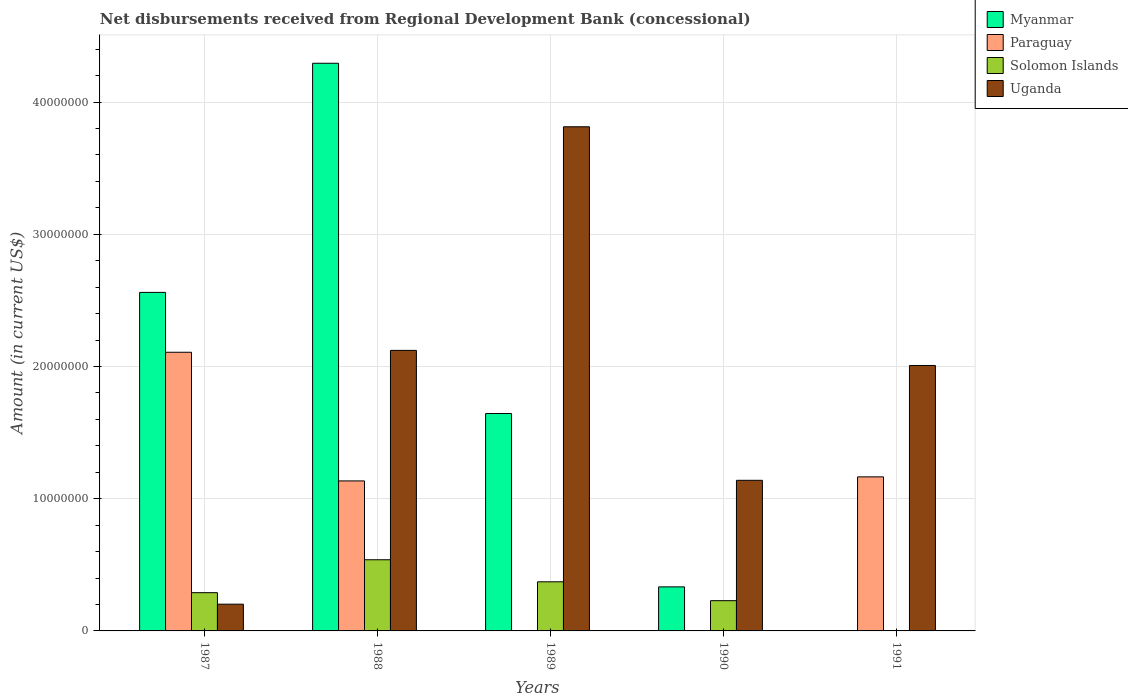How many groups of bars are there?
Give a very brief answer. 5. How many bars are there on the 5th tick from the right?
Your answer should be very brief. 4. What is the label of the 2nd group of bars from the left?
Your response must be concise. 1988. What is the amount of disbursements received from Regional Development Bank in Myanmar in 1987?
Offer a terse response. 2.56e+07. Across all years, what is the maximum amount of disbursements received from Regional Development Bank in Myanmar?
Your response must be concise. 4.29e+07. Across all years, what is the minimum amount of disbursements received from Regional Development Bank in Solomon Islands?
Your answer should be compact. 0. In which year was the amount of disbursements received from Regional Development Bank in Solomon Islands maximum?
Your answer should be compact. 1988. What is the total amount of disbursements received from Regional Development Bank in Uganda in the graph?
Give a very brief answer. 9.28e+07. What is the difference between the amount of disbursements received from Regional Development Bank in Myanmar in 1987 and that in 1988?
Your answer should be compact. -1.73e+07. What is the difference between the amount of disbursements received from Regional Development Bank in Myanmar in 1989 and the amount of disbursements received from Regional Development Bank in Uganda in 1991?
Your answer should be compact. -3.63e+06. What is the average amount of disbursements received from Regional Development Bank in Myanmar per year?
Keep it short and to the point. 1.77e+07. In the year 1990, what is the difference between the amount of disbursements received from Regional Development Bank in Myanmar and amount of disbursements received from Regional Development Bank in Uganda?
Your answer should be very brief. -8.06e+06. In how many years, is the amount of disbursements received from Regional Development Bank in Uganda greater than 32000000 US$?
Ensure brevity in your answer.  1. What is the ratio of the amount of disbursements received from Regional Development Bank in Uganda in 1988 to that in 1991?
Give a very brief answer. 1.06. Is the amount of disbursements received from Regional Development Bank in Uganda in 1987 less than that in 1988?
Provide a short and direct response. Yes. Is the difference between the amount of disbursements received from Regional Development Bank in Myanmar in 1987 and 1989 greater than the difference between the amount of disbursements received from Regional Development Bank in Uganda in 1987 and 1989?
Offer a terse response. Yes. What is the difference between the highest and the second highest amount of disbursements received from Regional Development Bank in Paraguay?
Your answer should be compact. 9.42e+06. What is the difference between the highest and the lowest amount of disbursements received from Regional Development Bank in Paraguay?
Keep it short and to the point. 2.11e+07. Is the sum of the amount of disbursements received from Regional Development Bank in Solomon Islands in 1989 and 1990 greater than the maximum amount of disbursements received from Regional Development Bank in Paraguay across all years?
Provide a succinct answer. No. Is it the case that in every year, the sum of the amount of disbursements received from Regional Development Bank in Uganda and amount of disbursements received from Regional Development Bank in Solomon Islands is greater than the sum of amount of disbursements received from Regional Development Bank in Paraguay and amount of disbursements received from Regional Development Bank in Myanmar?
Offer a very short reply. No. How many bars are there?
Keep it short and to the point. 16. Are all the bars in the graph horizontal?
Provide a succinct answer. No. How many years are there in the graph?
Your answer should be very brief. 5. What is the difference between two consecutive major ticks on the Y-axis?
Make the answer very short. 1.00e+07. Where does the legend appear in the graph?
Your answer should be very brief. Top right. How many legend labels are there?
Your answer should be very brief. 4. How are the legend labels stacked?
Offer a very short reply. Vertical. What is the title of the graph?
Provide a short and direct response. Net disbursements received from Regional Development Bank (concessional). Does "Northern Mariana Islands" appear as one of the legend labels in the graph?
Provide a succinct answer. No. What is the label or title of the X-axis?
Offer a terse response. Years. What is the label or title of the Y-axis?
Provide a short and direct response. Amount (in current US$). What is the Amount (in current US$) of Myanmar in 1987?
Make the answer very short. 2.56e+07. What is the Amount (in current US$) in Paraguay in 1987?
Provide a succinct answer. 2.11e+07. What is the Amount (in current US$) of Solomon Islands in 1987?
Offer a very short reply. 2.89e+06. What is the Amount (in current US$) in Uganda in 1987?
Keep it short and to the point. 2.02e+06. What is the Amount (in current US$) of Myanmar in 1988?
Keep it short and to the point. 4.29e+07. What is the Amount (in current US$) of Paraguay in 1988?
Your answer should be very brief. 1.13e+07. What is the Amount (in current US$) of Solomon Islands in 1988?
Keep it short and to the point. 5.38e+06. What is the Amount (in current US$) of Uganda in 1988?
Provide a succinct answer. 2.12e+07. What is the Amount (in current US$) of Myanmar in 1989?
Ensure brevity in your answer.  1.64e+07. What is the Amount (in current US$) in Paraguay in 1989?
Ensure brevity in your answer.  0. What is the Amount (in current US$) of Solomon Islands in 1989?
Give a very brief answer. 3.71e+06. What is the Amount (in current US$) of Uganda in 1989?
Give a very brief answer. 3.81e+07. What is the Amount (in current US$) in Myanmar in 1990?
Provide a short and direct response. 3.33e+06. What is the Amount (in current US$) in Solomon Islands in 1990?
Provide a succinct answer. 2.29e+06. What is the Amount (in current US$) of Uganda in 1990?
Keep it short and to the point. 1.14e+07. What is the Amount (in current US$) in Myanmar in 1991?
Offer a very short reply. 0. What is the Amount (in current US$) of Paraguay in 1991?
Provide a short and direct response. 1.16e+07. What is the Amount (in current US$) of Solomon Islands in 1991?
Your answer should be very brief. 0. What is the Amount (in current US$) of Uganda in 1991?
Your response must be concise. 2.01e+07. Across all years, what is the maximum Amount (in current US$) of Myanmar?
Keep it short and to the point. 4.29e+07. Across all years, what is the maximum Amount (in current US$) of Paraguay?
Ensure brevity in your answer.  2.11e+07. Across all years, what is the maximum Amount (in current US$) of Solomon Islands?
Provide a short and direct response. 5.38e+06. Across all years, what is the maximum Amount (in current US$) in Uganda?
Provide a succinct answer. 3.81e+07. Across all years, what is the minimum Amount (in current US$) in Paraguay?
Offer a very short reply. 0. Across all years, what is the minimum Amount (in current US$) in Solomon Islands?
Your answer should be very brief. 0. Across all years, what is the minimum Amount (in current US$) of Uganda?
Your answer should be very brief. 2.02e+06. What is the total Amount (in current US$) in Myanmar in the graph?
Offer a terse response. 8.83e+07. What is the total Amount (in current US$) in Paraguay in the graph?
Ensure brevity in your answer.  4.41e+07. What is the total Amount (in current US$) of Solomon Islands in the graph?
Provide a short and direct response. 1.43e+07. What is the total Amount (in current US$) in Uganda in the graph?
Your answer should be very brief. 9.28e+07. What is the difference between the Amount (in current US$) in Myanmar in 1987 and that in 1988?
Make the answer very short. -1.73e+07. What is the difference between the Amount (in current US$) in Paraguay in 1987 and that in 1988?
Offer a terse response. 9.73e+06. What is the difference between the Amount (in current US$) of Solomon Islands in 1987 and that in 1988?
Make the answer very short. -2.49e+06. What is the difference between the Amount (in current US$) of Uganda in 1987 and that in 1988?
Your answer should be very brief. -1.92e+07. What is the difference between the Amount (in current US$) in Myanmar in 1987 and that in 1989?
Your response must be concise. 9.16e+06. What is the difference between the Amount (in current US$) of Solomon Islands in 1987 and that in 1989?
Make the answer very short. -8.22e+05. What is the difference between the Amount (in current US$) in Uganda in 1987 and that in 1989?
Offer a very short reply. -3.61e+07. What is the difference between the Amount (in current US$) in Myanmar in 1987 and that in 1990?
Your answer should be compact. 2.23e+07. What is the difference between the Amount (in current US$) in Solomon Islands in 1987 and that in 1990?
Give a very brief answer. 6.05e+05. What is the difference between the Amount (in current US$) of Uganda in 1987 and that in 1990?
Your response must be concise. -9.37e+06. What is the difference between the Amount (in current US$) of Paraguay in 1987 and that in 1991?
Your answer should be very brief. 9.42e+06. What is the difference between the Amount (in current US$) of Uganda in 1987 and that in 1991?
Offer a very short reply. -1.81e+07. What is the difference between the Amount (in current US$) in Myanmar in 1988 and that in 1989?
Your answer should be very brief. 2.65e+07. What is the difference between the Amount (in current US$) in Solomon Islands in 1988 and that in 1989?
Give a very brief answer. 1.67e+06. What is the difference between the Amount (in current US$) in Uganda in 1988 and that in 1989?
Keep it short and to the point. -1.69e+07. What is the difference between the Amount (in current US$) in Myanmar in 1988 and that in 1990?
Provide a short and direct response. 3.96e+07. What is the difference between the Amount (in current US$) of Solomon Islands in 1988 and that in 1990?
Ensure brevity in your answer.  3.10e+06. What is the difference between the Amount (in current US$) of Uganda in 1988 and that in 1990?
Your response must be concise. 9.83e+06. What is the difference between the Amount (in current US$) of Paraguay in 1988 and that in 1991?
Give a very brief answer. -3.06e+05. What is the difference between the Amount (in current US$) of Uganda in 1988 and that in 1991?
Make the answer very short. 1.14e+06. What is the difference between the Amount (in current US$) of Myanmar in 1989 and that in 1990?
Your answer should be compact. 1.31e+07. What is the difference between the Amount (in current US$) of Solomon Islands in 1989 and that in 1990?
Give a very brief answer. 1.43e+06. What is the difference between the Amount (in current US$) of Uganda in 1989 and that in 1990?
Offer a terse response. 2.67e+07. What is the difference between the Amount (in current US$) in Uganda in 1989 and that in 1991?
Your answer should be compact. 1.81e+07. What is the difference between the Amount (in current US$) in Uganda in 1990 and that in 1991?
Provide a short and direct response. -8.68e+06. What is the difference between the Amount (in current US$) in Myanmar in 1987 and the Amount (in current US$) in Paraguay in 1988?
Give a very brief answer. 1.43e+07. What is the difference between the Amount (in current US$) in Myanmar in 1987 and the Amount (in current US$) in Solomon Islands in 1988?
Provide a succinct answer. 2.02e+07. What is the difference between the Amount (in current US$) in Myanmar in 1987 and the Amount (in current US$) in Uganda in 1988?
Give a very brief answer. 4.38e+06. What is the difference between the Amount (in current US$) in Paraguay in 1987 and the Amount (in current US$) in Solomon Islands in 1988?
Give a very brief answer. 1.57e+07. What is the difference between the Amount (in current US$) of Paraguay in 1987 and the Amount (in current US$) of Uganda in 1988?
Provide a short and direct response. -1.42e+05. What is the difference between the Amount (in current US$) of Solomon Islands in 1987 and the Amount (in current US$) of Uganda in 1988?
Provide a short and direct response. -1.83e+07. What is the difference between the Amount (in current US$) in Myanmar in 1987 and the Amount (in current US$) in Solomon Islands in 1989?
Give a very brief answer. 2.19e+07. What is the difference between the Amount (in current US$) of Myanmar in 1987 and the Amount (in current US$) of Uganda in 1989?
Offer a terse response. -1.25e+07. What is the difference between the Amount (in current US$) of Paraguay in 1987 and the Amount (in current US$) of Solomon Islands in 1989?
Offer a very short reply. 1.74e+07. What is the difference between the Amount (in current US$) in Paraguay in 1987 and the Amount (in current US$) in Uganda in 1989?
Offer a terse response. -1.71e+07. What is the difference between the Amount (in current US$) of Solomon Islands in 1987 and the Amount (in current US$) of Uganda in 1989?
Provide a short and direct response. -3.52e+07. What is the difference between the Amount (in current US$) in Myanmar in 1987 and the Amount (in current US$) in Solomon Islands in 1990?
Ensure brevity in your answer.  2.33e+07. What is the difference between the Amount (in current US$) in Myanmar in 1987 and the Amount (in current US$) in Uganda in 1990?
Give a very brief answer. 1.42e+07. What is the difference between the Amount (in current US$) in Paraguay in 1987 and the Amount (in current US$) in Solomon Islands in 1990?
Offer a very short reply. 1.88e+07. What is the difference between the Amount (in current US$) of Paraguay in 1987 and the Amount (in current US$) of Uganda in 1990?
Your answer should be very brief. 9.68e+06. What is the difference between the Amount (in current US$) of Solomon Islands in 1987 and the Amount (in current US$) of Uganda in 1990?
Keep it short and to the point. -8.50e+06. What is the difference between the Amount (in current US$) of Myanmar in 1987 and the Amount (in current US$) of Paraguay in 1991?
Ensure brevity in your answer.  1.40e+07. What is the difference between the Amount (in current US$) in Myanmar in 1987 and the Amount (in current US$) in Uganda in 1991?
Your response must be concise. 5.53e+06. What is the difference between the Amount (in current US$) in Paraguay in 1987 and the Amount (in current US$) in Uganda in 1991?
Keep it short and to the point. 9.99e+05. What is the difference between the Amount (in current US$) in Solomon Islands in 1987 and the Amount (in current US$) in Uganda in 1991?
Offer a terse response. -1.72e+07. What is the difference between the Amount (in current US$) of Myanmar in 1988 and the Amount (in current US$) of Solomon Islands in 1989?
Your answer should be compact. 3.92e+07. What is the difference between the Amount (in current US$) of Myanmar in 1988 and the Amount (in current US$) of Uganda in 1989?
Your response must be concise. 4.80e+06. What is the difference between the Amount (in current US$) of Paraguay in 1988 and the Amount (in current US$) of Solomon Islands in 1989?
Give a very brief answer. 7.63e+06. What is the difference between the Amount (in current US$) of Paraguay in 1988 and the Amount (in current US$) of Uganda in 1989?
Provide a short and direct response. -2.68e+07. What is the difference between the Amount (in current US$) of Solomon Islands in 1988 and the Amount (in current US$) of Uganda in 1989?
Make the answer very short. -3.27e+07. What is the difference between the Amount (in current US$) in Myanmar in 1988 and the Amount (in current US$) in Solomon Islands in 1990?
Ensure brevity in your answer.  4.06e+07. What is the difference between the Amount (in current US$) in Myanmar in 1988 and the Amount (in current US$) in Uganda in 1990?
Offer a terse response. 3.15e+07. What is the difference between the Amount (in current US$) of Paraguay in 1988 and the Amount (in current US$) of Solomon Islands in 1990?
Your answer should be very brief. 9.06e+06. What is the difference between the Amount (in current US$) in Paraguay in 1988 and the Amount (in current US$) in Uganda in 1990?
Give a very brief answer. -4.60e+04. What is the difference between the Amount (in current US$) of Solomon Islands in 1988 and the Amount (in current US$) of Uganda in 1990?
Provide a short and direct response. -6.01e+06. What is the difference between the Amount (in current US$) in Myanmar in 1988 and the Amount (in current US$) in Paraguay in 1991?
Give a very brief answer. 3.13e+07. What is the difference between the Amount (in current US$) of Myanmar in 1988 and the Amount (in current US$) of Uganda in 1991?
Your response must be concise. 2.29e+07. What is the difference between the Amount (in current US$) in Paraguay in 1988 and the Amount (in current US$) in Uganda in 1991?
Provide a succinct answer. -8.73e+06. What is the difference between the Amount (in current US$) of Solomon Islands in 1988 and the Amount (in current US$) of Uganda in 1991?
Keep it short and to the point. -1.47e+07. What is the difference between the Amount (in current US$) in Myanmar in 1989 and the Amount (in current US$) in Solomon Islands in 1990?
Your response must be concise. 1.42e+07. What is the difference between the Amount (in current US$) of Myanmar in 1989 and the Amount (in current US$) of Uganda in 1990?
Your response must be concise. 5.05e+06. What is the difference between the Amount (in current US$) of Solomon Islands in 1989 and the Amount (in current US$) of Uganda in 1990?
Offer a terse response. -7.68e+06. What is the difference between the Amount (in current US$) of Myanmar in 1989 and the Amount (in current US$) of Paraguay in 1991?
Make the answer very short. 4.79e+06. What is the difference between the Amount (in current US$) in Myanmar in 1989 and the Amount (in current US$) in Uganda in 1991?
Provide a short and direct response. -3.63e+06. What is the difference between the Amount (in current US$) in Solomon Islands in 1989 and the Amount (in current US$) in Uganda in 1991?
Make the answer very short. -1.64e+07. What is the difference between the Amount (in current US$) of Myanmar in 1990 and the Amount (in current US$) of Paraguay in 1991?
Your answer should be compact. -8.32e+06. What is the difference between the Amount (in current US$) in Myanmar in 1990 and the Amount (in current US$) in Uganda in 1991?
Your response must be concise. -1.67e+07. What is the difference between the Amount (in current US$) of Solomon Islands in 1990 and the Amount (in current US$) of Uganda in 1991?
Offer a very short reply. -1.78e+07. What is the average Amount (in current US$) of Myanmar per year?
Make the answer very short. 1.77e+07. What is the average Amount (in current US$) in Paraguay per year?
Provide a short and direct response. 8.81e+06. What is the average Amount (in current US$) of Solomon Islands per year?
Ensure brevity in your answer.  2.86e+06. What is the average Amount (in current US$) of Uganda per year?
Your answer should be very brief. 1.86e+07. In the year 1987, what is the difference between the Amount (in current US$) in Myanmar and Amount (in current US$) in Paraguay?
Your answer should be very brief. 4.53e+06. In the year 1987, what is the difference between the Amount (in current US$) in Myanmar and Amount (in current US$) in Solomon Islands?
Offer a very short reply. 2.27e+07. In the year 1987, what is the difference between the Amount (in current US$) of Myanmar and Amount (in current US$) of Uganda?
Your response must be concise. 2.36e+07. In the year 1987, what is the difference between the Amount (in current US$) in Paraguay and Amount (in current US$) in Solomon Islands?
Offer a very short reply. 1.82e+07. In the year 1987, what is the difference between the Amount (in current US$) of Paraguay and Amount (in current US$) of Uganda?
Offer a terse response. 1.91e+07. In the year 1987, what is the difference between the Amount (in current US$) of Solomon Islands and Amount (in current US$) of Uganda?
Your answer should be very brief. 8.70e+05. In the year 1988, what is the difference between the Amount (in current US$) in Myanmar and Amount (in current US$) in Paraguay?
Keep it short and to the point. 3.16e+07. In the year 1988, what is the difference between the Amount (in current US$) of Myanmar and Amount (in current US$) of Solomon Islands?
Provide a succinct answer. 3.75e+07. In the year 1988, what is the difference between the Amount (in current US$) in Myanmar and Amount (in current US$) in Uganda?
Make the answer very short. 2.17e+07. In the year 1988, what is the difference between the Amount (in current US$) of Paraguay and Amount (in current US$) of Solomon Islands?
Your response must be concise. 5.96e+06. In the year 1988, what is the difference between the Amount (in current US$) in Paraguay and Amount (in current US$) in Uganda?
Provide a succinct answer. -9.87e+06. In the year 1988, what is the difference between the Amount (in current US$) of Solomon Islands and Amount (in current US$) of Uganda?
Offer a terse response. -1.58e+07. In the year 1989, what is the difference between the Amount (in current US$) of Myanmar and Amount (in current US$) of Solomon Islands?
Offer a terse response. 1.27e+07. In the year 1989, what is the difference between the Amount (in current US$) of Myanmar and Amount (in current US$) of Uganda?
Provide a succinct answer. -2.17e+07. In the year 1989, what is the difference between the Amount (in current US$) in Solomon Islands and Amount (in current US$) in Uganda?
Your response must be concise. -3.44e+07. In the year 1990, what is the difference between the Amount (in current US$) of Myanmar and Amount (in current US$) of Solomon Islands?
Keep it short and to the point. 1.04e+06. In the year 1990, what is the difference between the Amount (in current US$) in Myanmar and Amount (in current US$) in Uganda?
Ensure brevity in your answer.  -8.06e+06. In the year 1990, what is the difference between the Amount (in current US$) of Solomon Islands and Amount (in current US$) of Uganda?
Ensure brevity in your answer.  -9.10e+06. In the year 1991, what is the difference between the Amount (in current US$) in Paraguay and Amount (in current US$) in Uganda?
Ensure brevity in your answer.  -8.42e+06. What is the ratio of the Amount (in current US$) in Myanmar in 1987 to that in 1988?
Ensure brevity in your answer.  0.6. What is the ratio of the Amount (in current US$) of Paraguay in 1987 to that in 1988?
Ensure brevity in your answer.  1.86. What is the ratio of the Amount (in current US$) of Solomon Islands in 1987 to that in 1988?
Your answer should be compact. 0.54. What is the ratio of the Amount (in current US$) of Uganda in 1987 to that in 1988?
Your answer should be very brief. 0.1. What is the ratio of the Amount (in current US$) in Myanmar in 1987 to that in 1989?
Offer a very short reply. 1.56. What is the ratio of the Amount (in current US$) in Solomon Islands in 1987 to that in 1989?
Make the answer very short. 0.78. What is the ratio of the Amount (in current US$) in Uganda in 1987 to that in 1989?
Provide a succinct answer. 0.05. What is the ratio of the Amount (in current US$) of Myanmar in 1987 to that in 1990?
Your answer should be compact. 7.69. What is the ratio of the Amount (in current US$) of Solomon Islands in 1987 to that in 1990?
Give a very brief answer. 1.26. What is the ratio of the Amount (in current US$) in Uganda in 1987 to that in 1990?
Your response must be concise. 0.18. What is the ratio of the Amount (in current US$) in Paraguay in 1987 to that in 1991?
Your response must be concise. 1.81. What is the ratio of the Amount (in current US$) of Uganda in 1987 to that in 1991?
Ensure brevity in your answer.  0.1. What is the ratio of the Amount (in current US$) of Myanmar in 1988 to that in 1989?
Make the answer very short. 2.61. What is the ratio of the Amount (in current US$) of Solomon Islands in 1988 to that in 1989?
Keep it short and to the point. 1.45. What is the ratio of the Amount (in current US$) in Uganda in 1988 to that in 1989?
Give a very brief answer. 0.56. What is the ratio of the Amount (in current US$) in Myanmar in 1988 to that in 1990?
Your answer should be very brief. 12.89. What is the ratio of the Amount (in current US$) in Solomon Islands in 1988 to that in 1990?
Offer a very short reply. 2.35. What is the ratio of the Amount (in current US$) in Uganda in 1988 to that in 1990?
Your answer should be compact. 1.86. What is the ratio of the Amount (in current US$) in Paraguay in 1988 to that in 1991?
Ensure brevity in your answer.  0.97. What is the ratio of the Amount (in current US$) of Uganda in 1988 to that in 1991?
Provide a succinct answer. 1.06. What is the ratio of the Amount (in current US$) of Myanmar in 1989 to that in 1990?
Offer a terse response. 4.94. What is the ratio of the Amount (in current US$) in Solomon Islands in 1989 to that in 1990?
Ensure brevity in your answer.  1.62. What is the ratio of the Amount (in current US$) of Uganda in 1989 to that in 1990?
Your answer should be compact. 3.35. What is the ratio of the Amount (in current US$) in Uganda in 1989 to that in 1991?
Provide a short and direct response. 1.9. What is the ratio of the Amount (in current US$) of Uganda in 1990 to that in 1991?
Give a very brief answer. 0.57. What is the difference between the highest and the second highest Amount (in current US$) in Myanmar?
Give a very brief answer. 1.73e+07. What is the difference between the highest and the second highest Amount (in current US$) in Paraguay?
Your answer should be compact. 9.42e+06. What is the difference between the highest and the second highest Amount (in current US$) of Solomon Islands?
Offer a very short reply. 1.67e+06. What is the difference between the highest and the second highest Amount (in current US$) of Uganda?
Keep it short and to the point. 1.69e+07. What is the difference between the highest and the lowest Amount (in current US$) in Myanmar?
Give a very brief answer. 4.29e+07. What is the difference between the highest and the lowest Amount (in current US$) of Paraguay?
Provide a short and direct response. 2.11e+07. What is the difference between the highest and the lowest Amount (in current US$) of Solomon Islands?
Provide a succinct answer. 5.38e+06. What is the difference between the highest and the lowest Amount (in current US$) of Uganda?
Provide a succinct answer. 3.61e+07. 